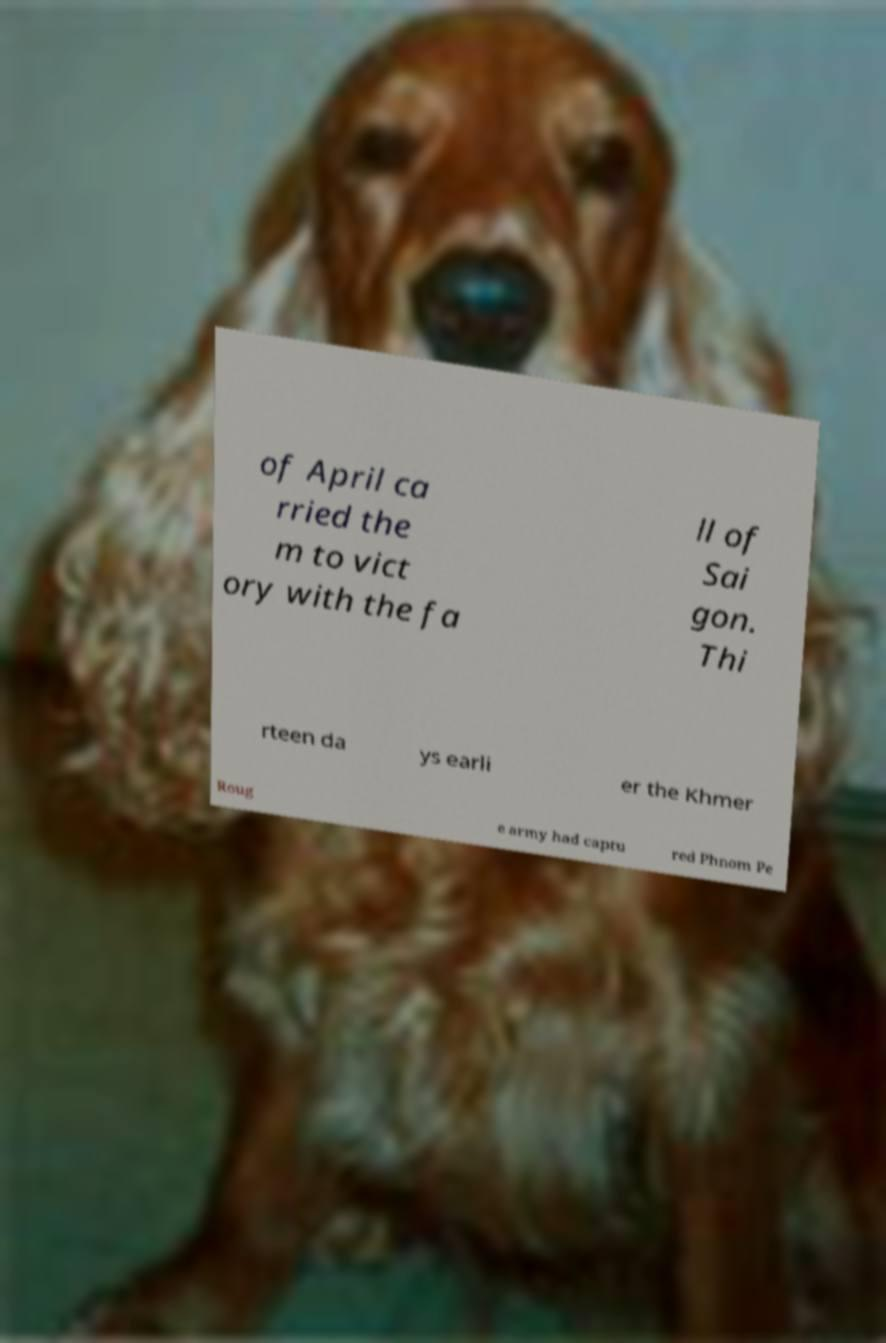Could you extract and type out the text from this image? of April ca rried the m to vict ory with the fa ll of Sai gon. Thi rteen da ys earli er the Khmer Roug e army had captu red Phnom Pe 